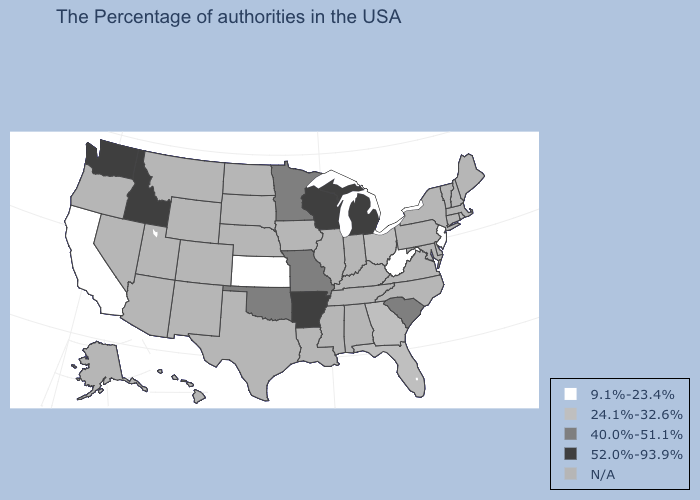What is the value of Iowa?
Short answer required. N/A. What is the value of Wisconsin?
Write a very short answer. 52.0%-93.9%. Among the states that border Idaho , which have the highest value?
Be succinct. Washington. What is the highest value in states that border Montana?
Write a very short answer. 52.0%-93.9%. Name the states that have a value in the range 9.1%-23.4%?
Keep it brief. New Jersey, West Virginia, Kansas, California. What is the highest value in the South ?
Be succinct. 52.0%-93.9%. How many symbols are there in the legend?
Concise answer only. 5. Name the states that have a value in the range N/A?
Give a very brief answer. Maine, Massachusetts, New Hampshire, Vermont, Connecticut, New York, Delaware, Maryland, Pennsylvania, Virginia, North Carolina, Kentucky, Indiana, Alabama, Tennessee, Illinois, Mississippi, Louisiana, Iowa, Nebraska, Texas, South Dakota, North Dakota, Wyoming, Colorado, New Mexico, Utah, Montana, Arizona, Nevada, Oregon, Alaska, Hawaii. What is the lowest value in the USA?
Quick response, please. 9.1%-23.4%. What is the value of Rhode Island?
Give a very brief answer. 24.1%-32.6%. Does Kansas have the highest value in the MidWest?
Quick response, please. No. What is the lowest value in the South?
Write a very short answer. 9.1%-23.4%. What is the lowest value in the USA?
Answer briefly. 9.1%-23.4%. 